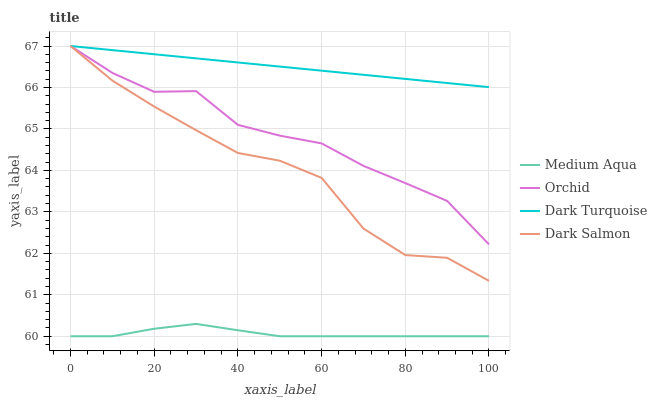Does Dark Salmon have the minimum area under the curve?
Answer yes or no. No. Does Dark Salmon have the maximum area under the curve?
Answer yes or no. No. Is Medium Aqua the smoothest?
Answer yes or no. No. Is Medium Aqua the roughest?
Answer yes or no. No. Does Dark Salmon have the lowest value?
Answer yes or no. No. Does Medium Aqua have the highest value?
Answer yes or no. No. Is Medium Aqua less than Orchid?
Answer yes or no. Yes. Is Dark Salmon greater than Medium Aqua?
Answer yes or no. Yes. Does Medium Aqua intersect Orchid?
Answer yes or no. No. 